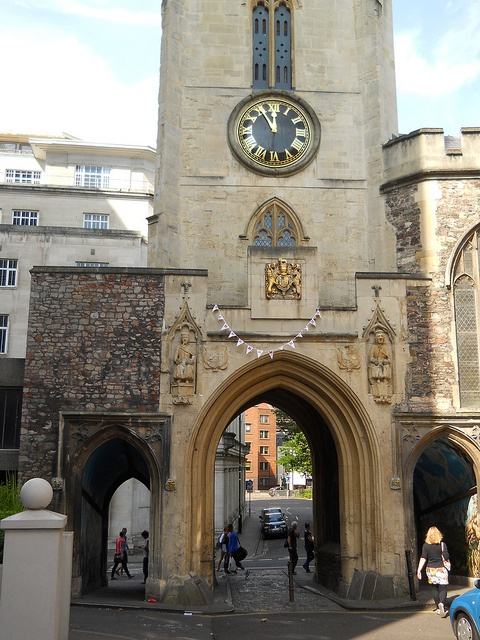Describe the objects in this image and their specific colors. I can see clock in white, gray, darkgray, and black tones, people in white, black, gray, ivory, and tan tones, car in white, gray, darkgray, and lightblue tones, people in white, black, gray, and maroon tones, and car in white, black, gray, and navy tones in this image. 